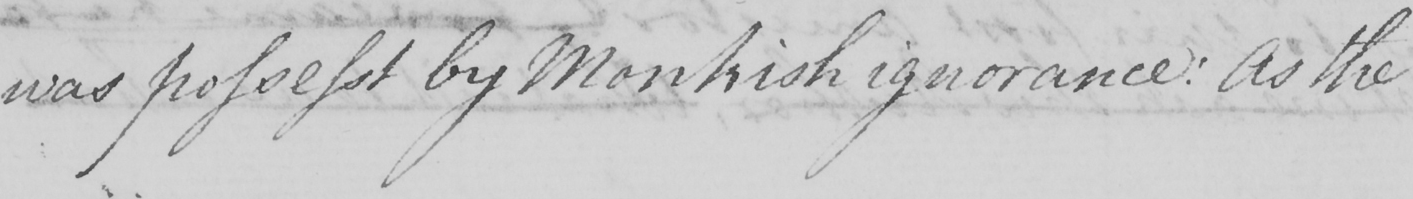Can you tell me what this handwritten text says? was possesst by Monkish ignorance :  As the 